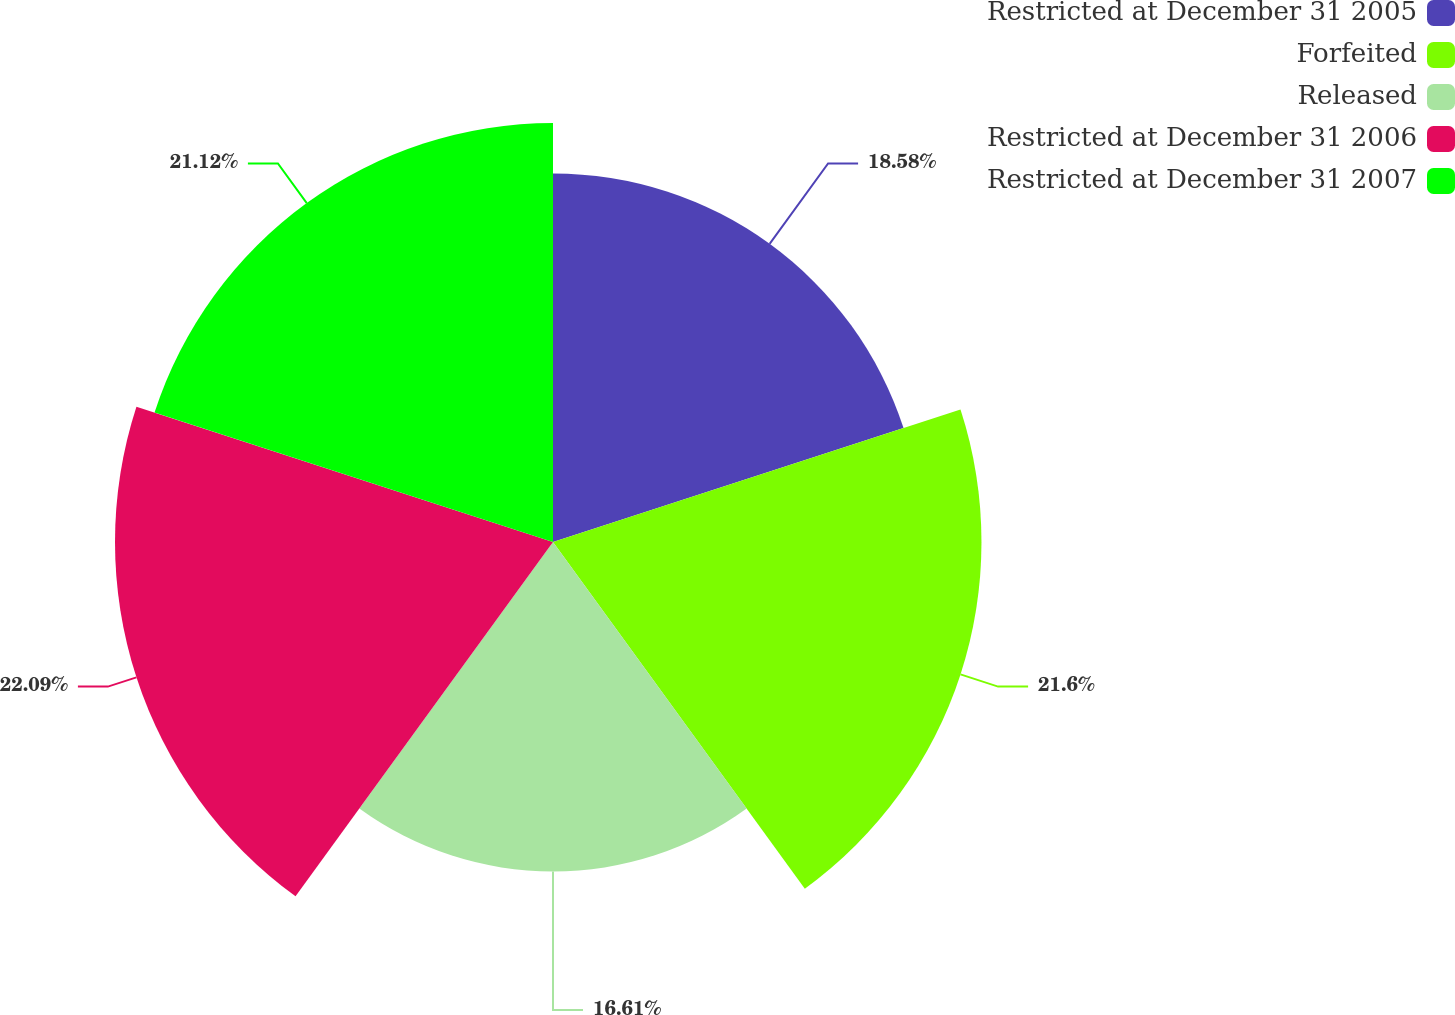<chart> <loc_0><loc_0><loc_500><loc_500><pie_chart><fcel>Restricted at December 31 2005<fcel>Forfeited<fcel>Released<fcel>Restricted at December 31 2006<fcel>Restricted at December 31 2007<nl><fcel>18.58%<fcel>21.6%<fcel>16.61%<fcel>22.08%<fcel>21.12%<nl></chart> 